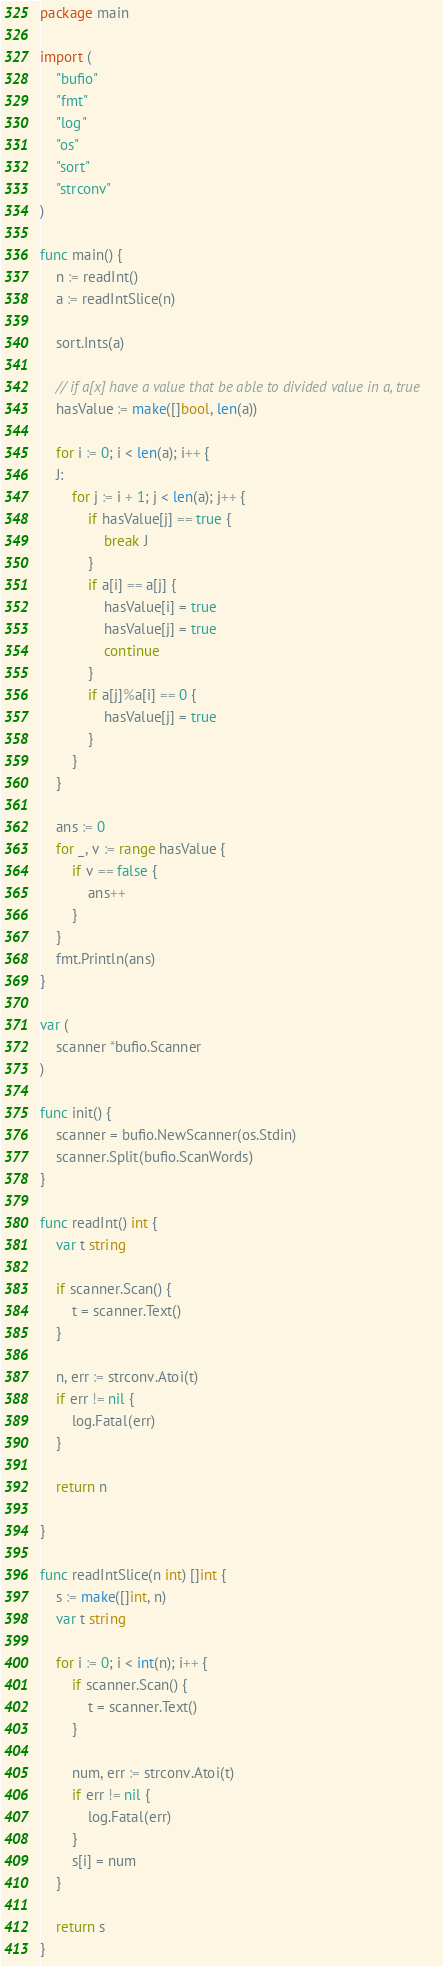<code> <loc_0><loc_0><loc_500><loc_500><_Go_>package main

import (
	"bufio"
	"fmt"
	"log"
	"os"
	"sort"
	"strconv"
)

func main() {
	n := readInt()
	a := readIntSlice(n)

	sort.Ints(a)

	// if a[x] have a value that be able to divided value in a, true
	hasValue := make([]bool, len(a))

	for i := 0; i < len(a); i++ {
	J:
		for j := i + 1; j < len(a); j++ {
			if hasValue[j] == true {
				break J
			}
			if a[i] == a[j] {
				hasValue[i] = true
				hasValue[j] = true
				continue
			}
			if a[j]%a[i] == 0 {
				hasValue[j] = true
			}
		}
	}

	ans := 0
	for _, v := range hasValue {
		if v == false {
			ans++
		}
	}
	fmt.Println(ans)
}

var (
	scanner *bufio.Scanner
)

func init() {
	scanner = bufio.NewScanner(os.Stdin)
	scanner.Split(bufio.ScanWords)
}

func readInt() int {
	var t string

	if scanner.Scan() {
		t = scanner.Text()
	}

	n, err := strconv.Atoi(t)
	if err != nil {
		log.Fatal(err)
	}

	return n

}

func readIntSlice(n int) []int {
	s := make([]int, n)
	var t string

	for i := 0; i < int(n); i++ {
		if scanner.Scan() {
			t = scanner.Text()
		}

		num, err := strconv.Atoi(t)
		if err != nil {
			log.Fatal(err)
		}
		s[i] = num
	}

	return s
}
</code> 